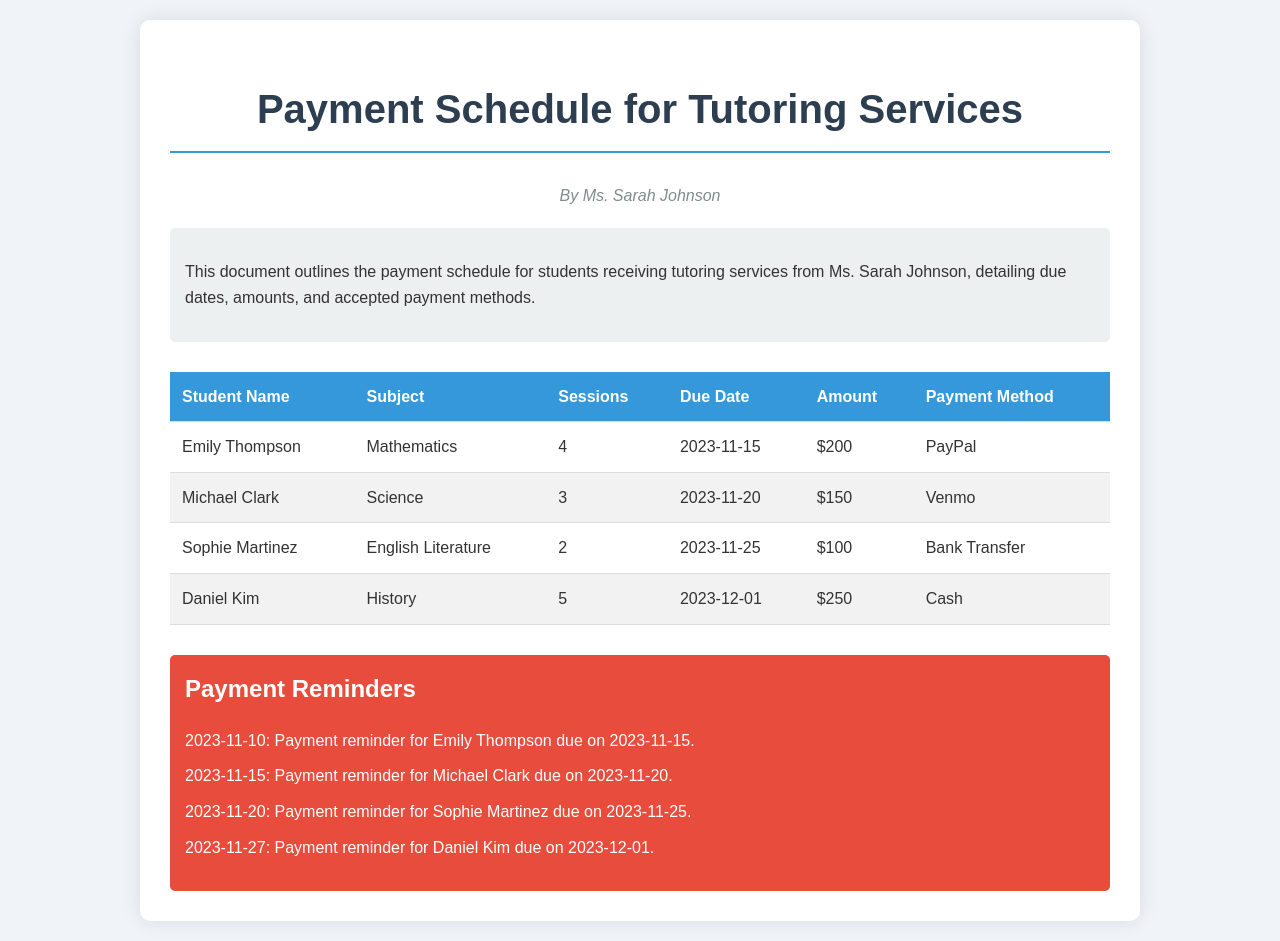What is the due date for Emily Thompson's payment? The due date for Emily Thompson's payment is listed in the document under her details, which is 2023-11-15.
Answer: 2023-11-15 How much is the total amount due for Daniel Kim? The total amount due for Daniel Kim is indicated in the document as $250, reflecting the charge for his tutoring sessions.
Answer: $250 Which payment method is accepted for Sophie Martinez? The payment method for Sophie Martinez is stated in her row, which is Bank Transfer.
Answer: Bank Transfer How many sessions did Michael Clark have? The number of sessions for Michael Clark is noted in the document as 3.
Answer: 3 What is the reminder date for Emily Thompson's payment? The reminder date for Emily Thompson's payment is specified in the reminders section, which is 2023-11-10.
Answer: 2023-11-10 Which subject is taught to Daniel Kim? The subject that Daniel Kim is receiving tutoring for is listed as History in the document.
Answer: History How many students are listed in the payment schedule? The total number of students in the payment schedule can be counted from the table in the document, which shows 4 students.
Answer: 4 What is the earliest payment due date mentioned? The earliest payment due date is found by examining the table, which is for Emily Thompson, due on 2023-11-15.
Answer: 2023-11-15 What amount is due from Sophie Martinez? The amount due from Sophie Martinez is shown in the document, which is $100.
Answer: $100 